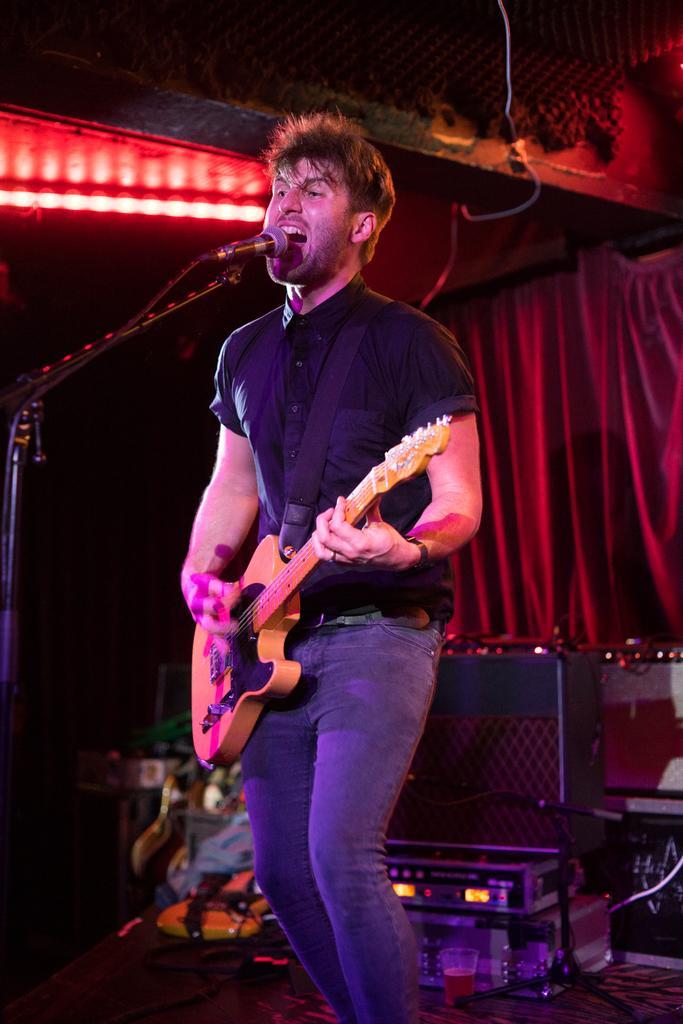How would you summarize this image in a sentence or two? On the background we can see curtain in red colour. These are lights here. we can see one man standing on a platform in front of a mike ,playing guitar and singing. 